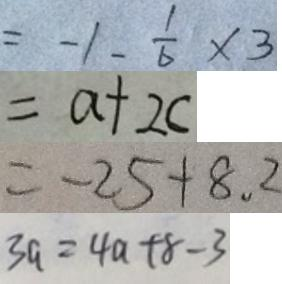<formula> <loc_0><loc_0><loc_500><loc_500>= - 1 - \frac { 1 } { 6 } \times 3 
 = a + 2 c 
 = - 2 5 + 8 . 2 
 3 a = 4 a + 8 - 3</formula> 